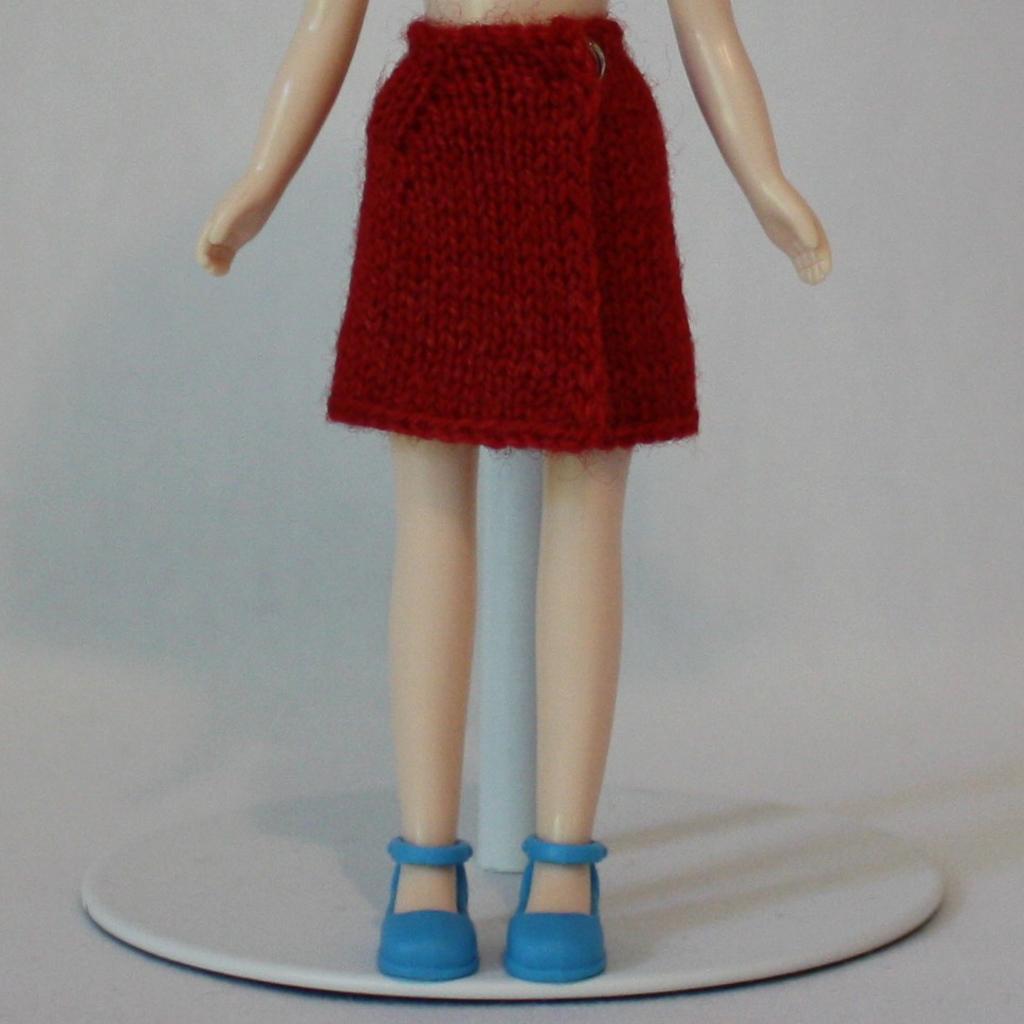In one or two sentences, can you explain what this image depicts? In this image there is a standing toy wearing skirt. 